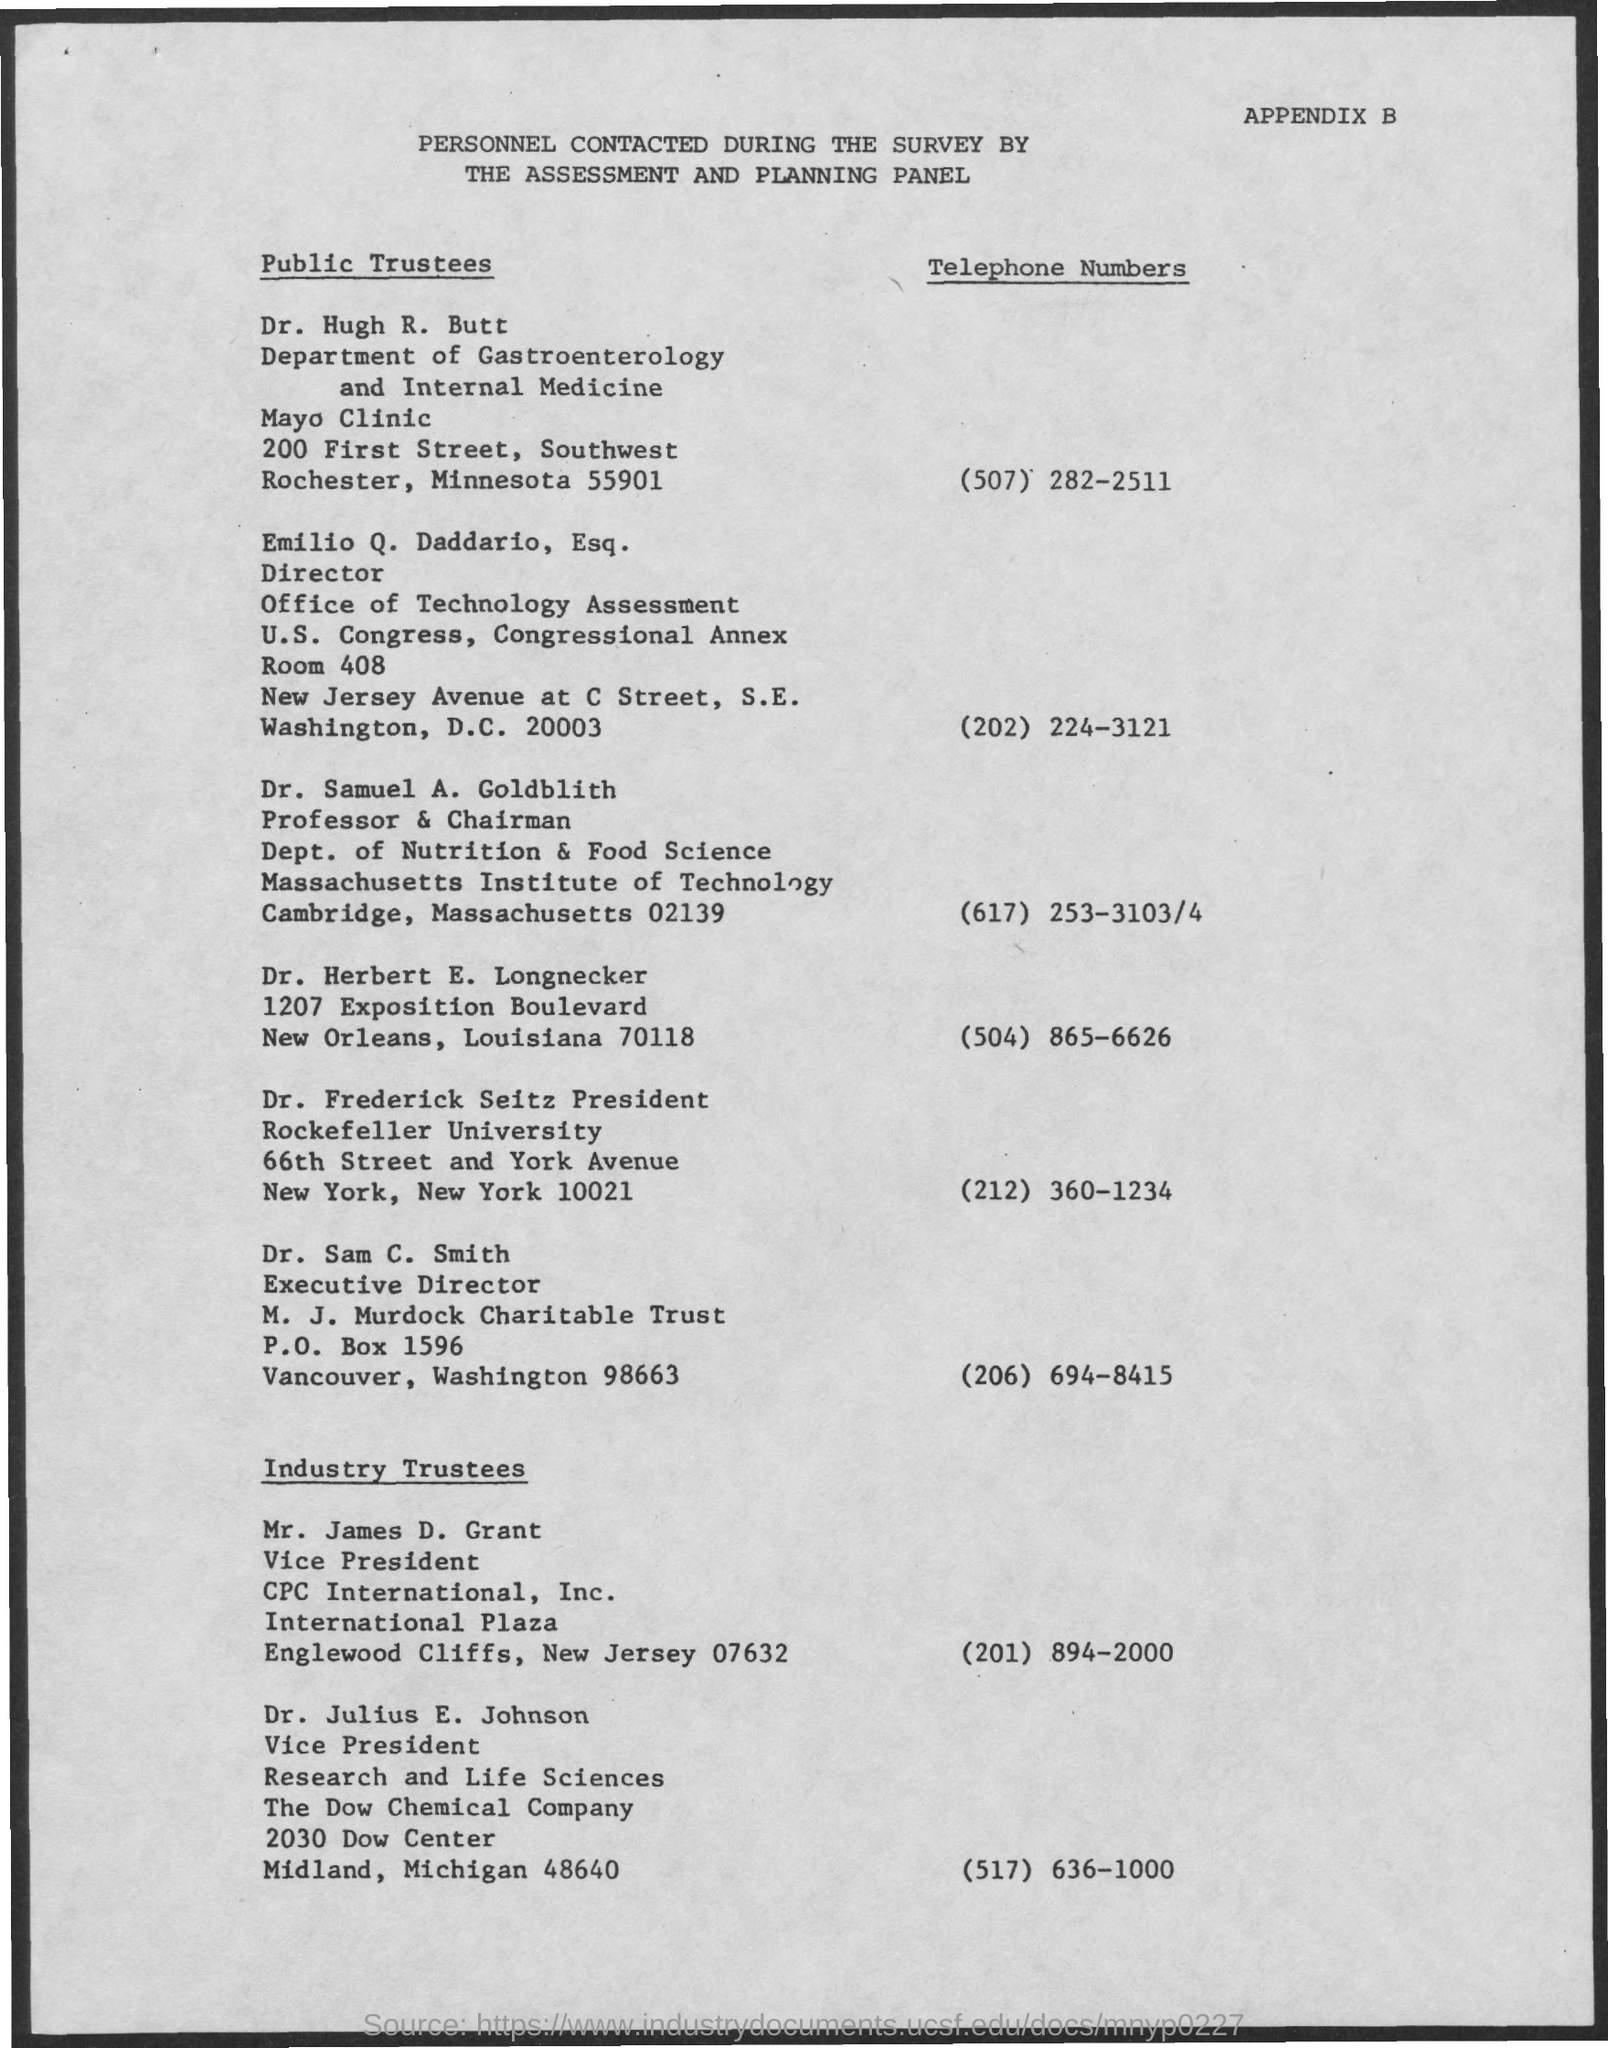What is the telephone number of Dr. Sam C. Smith?
Your answer should be compact. (206) 694-8415. What is the designation of dr.samuel a.goldblith ?
Offer a terse response. Professor & Chairman. 